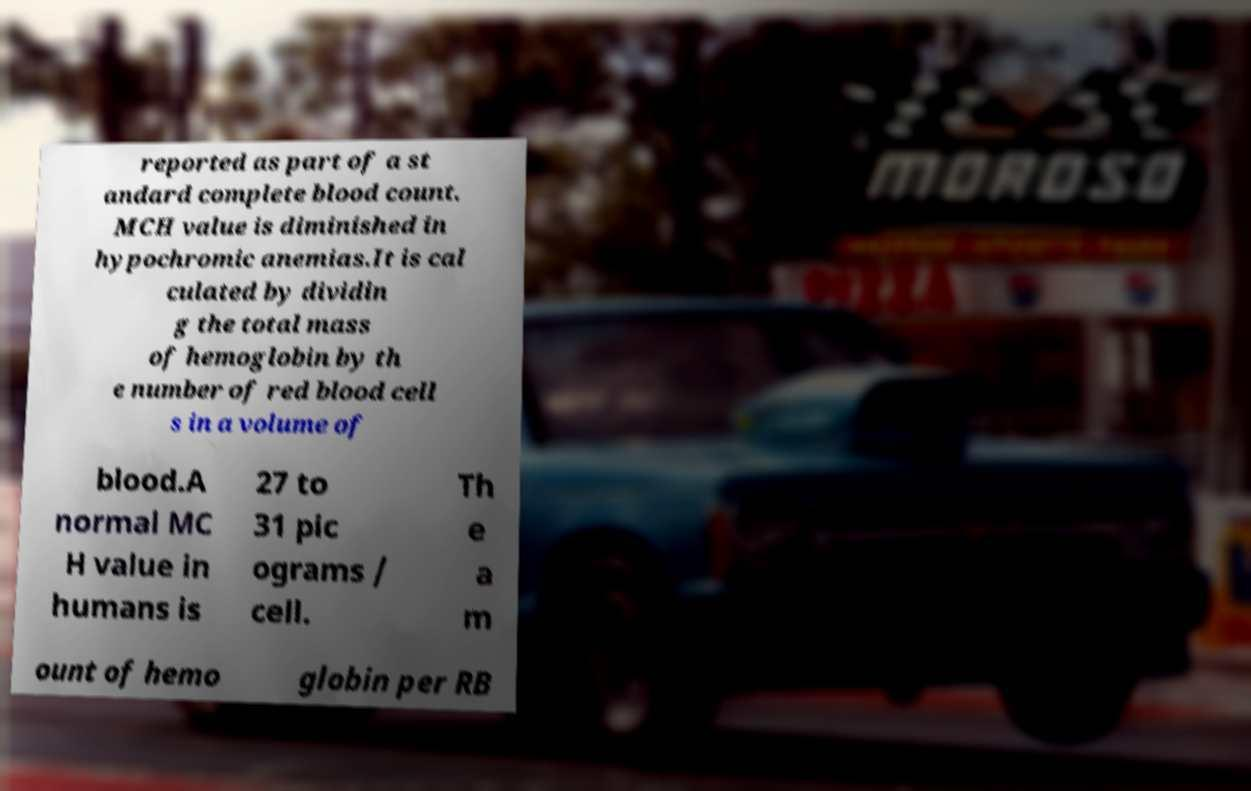Can you read and provide the text displayed in the image?This photo seems to have some interesting text. Can you extract and type it out for me? reported as part of a st andard complete blood count. MCH value is diminished in hypochromic anemias.It is cal culated by dividin g the total mass of hemoglobin by th e number of red blood cell s in a volume of blood.A normal MC H value in humans is 27 to 31 pic ograms / cell. Th e a m ount of hemo globin per RB 